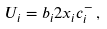<formula> <loc_0><loc_0><loc_500><loc_500>U _ { i } = b _ { i } 2 x _ { i } c _ { i } ^ { - } \, ,</formula> 